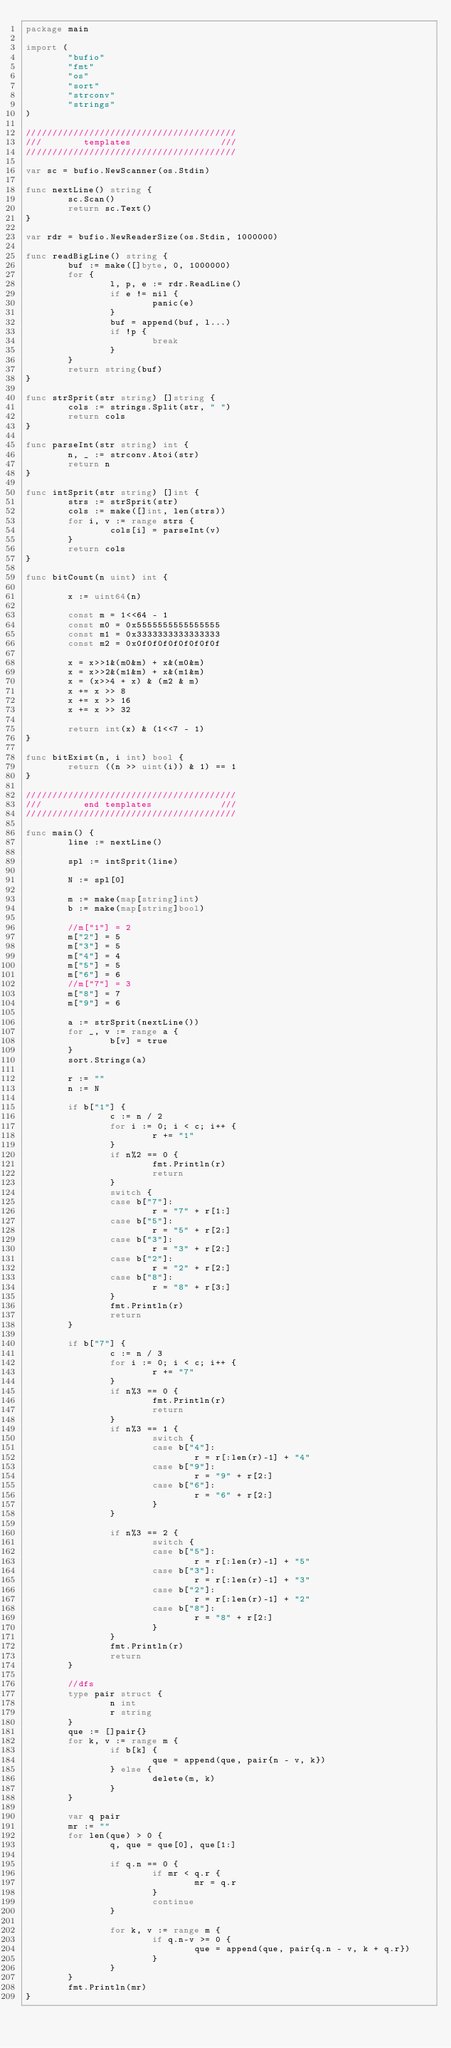<code> <loc_0><loc_0><loc_500><loc_500><_Go_>package main

import (
        "bufio"
        "fmt"
        "os"
        "sort"
        "strconv"
        "strings"
)

////////////////////////////////////////
///        templates                 ///
////////////////////////////////////////

var sc = bufio.NewScanner(os.Stdin)

func nextLine() string {
        sc.Scan()
        return sc.Text()
}

var rdr = bufio.NewReaderSize(os.Stdin, 1000000)

func readBigLine() string {
        buf := make([]byte, 0, 1000000)
        for {
                l, p, e := rdr.ReadLine()
                if e != nil {
                        panic(e)
                }
                buf = append(buf, l...)
                if !p {
                        break
                }
        }
        return string(buf)
}

func strSprit(str string) []string {
        cols := strings.Split(str, " ")
        return cols
}

func parseInt(str string) int {
        n, _ := strconv.Atoi(str)
        return n
}

func intSprit(str string) []int {
        strs := strSprit(str)
        cols := make([]int, len(strs))
        for i, v := range strs {
                cols[i] = parseInt(v)
        }
        return cols
}

func bitCount(n uint) int {

        x := uint64(n)

        const m = 1<<64 - 1
        const m0 = 0x5555555555555555
        const m1 = 0x3333333333333333
        const m2 = 0x0f0f0f0f0f0f0f0f

        x = x>>1&(m0&m) + x&(m0&m)
        x = x>>2&(m1&m) + x&(m1&m)
        x = (x>>4 + x) & (m2 & m)
        x += x >> 8
        x += x >> 16
        x += x >> 32

        return int(x) & (1<<7 - 1)
}

func bitExist(n, i int) bool {
        return ((n >> uint(i)) & 1) == 1
}

////////////////////////////////////////
///        end templates             ///
////////////////////////////////////////

func main() {
        line := nextLine()

        spl := intSprit(line)

        N := spl[0]

        m := make(map[string]int)
        b := make(map[string]bool)

        //m["1"] = 2
        m["2"] = 5
        m["3"] = 5
        m["4"] = 4
        m["5"] = 5
        m["6"] = 6
        //m["7"] = 3
        m["8"] = 7
        m["9"] = 6

        a := strSprit(nextLine())
        for _, v := range a {
                b[v] = true
        }
        sort.Strings(a)

        r := ""
        n := N

        if b["1"] {
                c := n / 2
                for i := 0; i < c; i++ {
                        r += "1"
                }
                if n%2 == 0 {
                        fmt.Println(r)
                        return
                }
                switch {
                case b["7"]:
                        r = "7" + r[1:]
                case b["5"]:
                        r = "5" + r[2:]
                case b["3"]:
                        r = "3" + r[2:]
                case b["2"]:
                        r = "2" + r[2:]
                case b["8"]:
                        r = "8" + r[3:]
                }
                fmt.Println(r)
                return
        }

        if b["7"] {
                c := n / 3
                for i := 0; i < c; i++ {
                        r += "7"
                }
                if n%3 == 0 {
                        fmt.Println(r)
                        return
                }
                if n%3 == 1 {
                        switch {
                        case b["4"]:
                                r = r[:len(r)-1] + "4"
                        case b["9"]:
                                r = "9" + r[2:]
                        case b["6"]:
                                r = "6" + r[2:]
                        }
                }

                if n%3 == 2 {
                        switch {
                        case b["5"]:
                                r = r[:len(r)-1] + "5"
                        case b["3"]:
                                r = r[:len(r)-1] + "3"
                        case b["2"]:
                                r = r[:len(r)-1] + "2"
                        case b["8"]:
                                r = "8" + r[2:]
                        }
                }
                fmt.Println(r)
                return
        }

        //dfs
        type pair struct {
                n int
                r string
        }
        que := []pair{}
        for k, v := range m {
                if b[k] {
                        que = append(que, pair{n - v, k})
                } else {
                        delete(m, k)
                }
        }

        var q pair
        mr := ""
        for len(que) > 0 {
                q, que = que[0], que[1:]

                if q.n == 0 {
                        if mr < q.r {
                                mr = q.r
                        }
                        continue
                }

                for k, v := range m {
                        if q.n-v >= 0 {
                                que = append(que, pair{q.n - v, k + q.r})
                        }
                }
        }
        fmt.Println(mr)
}</code> 